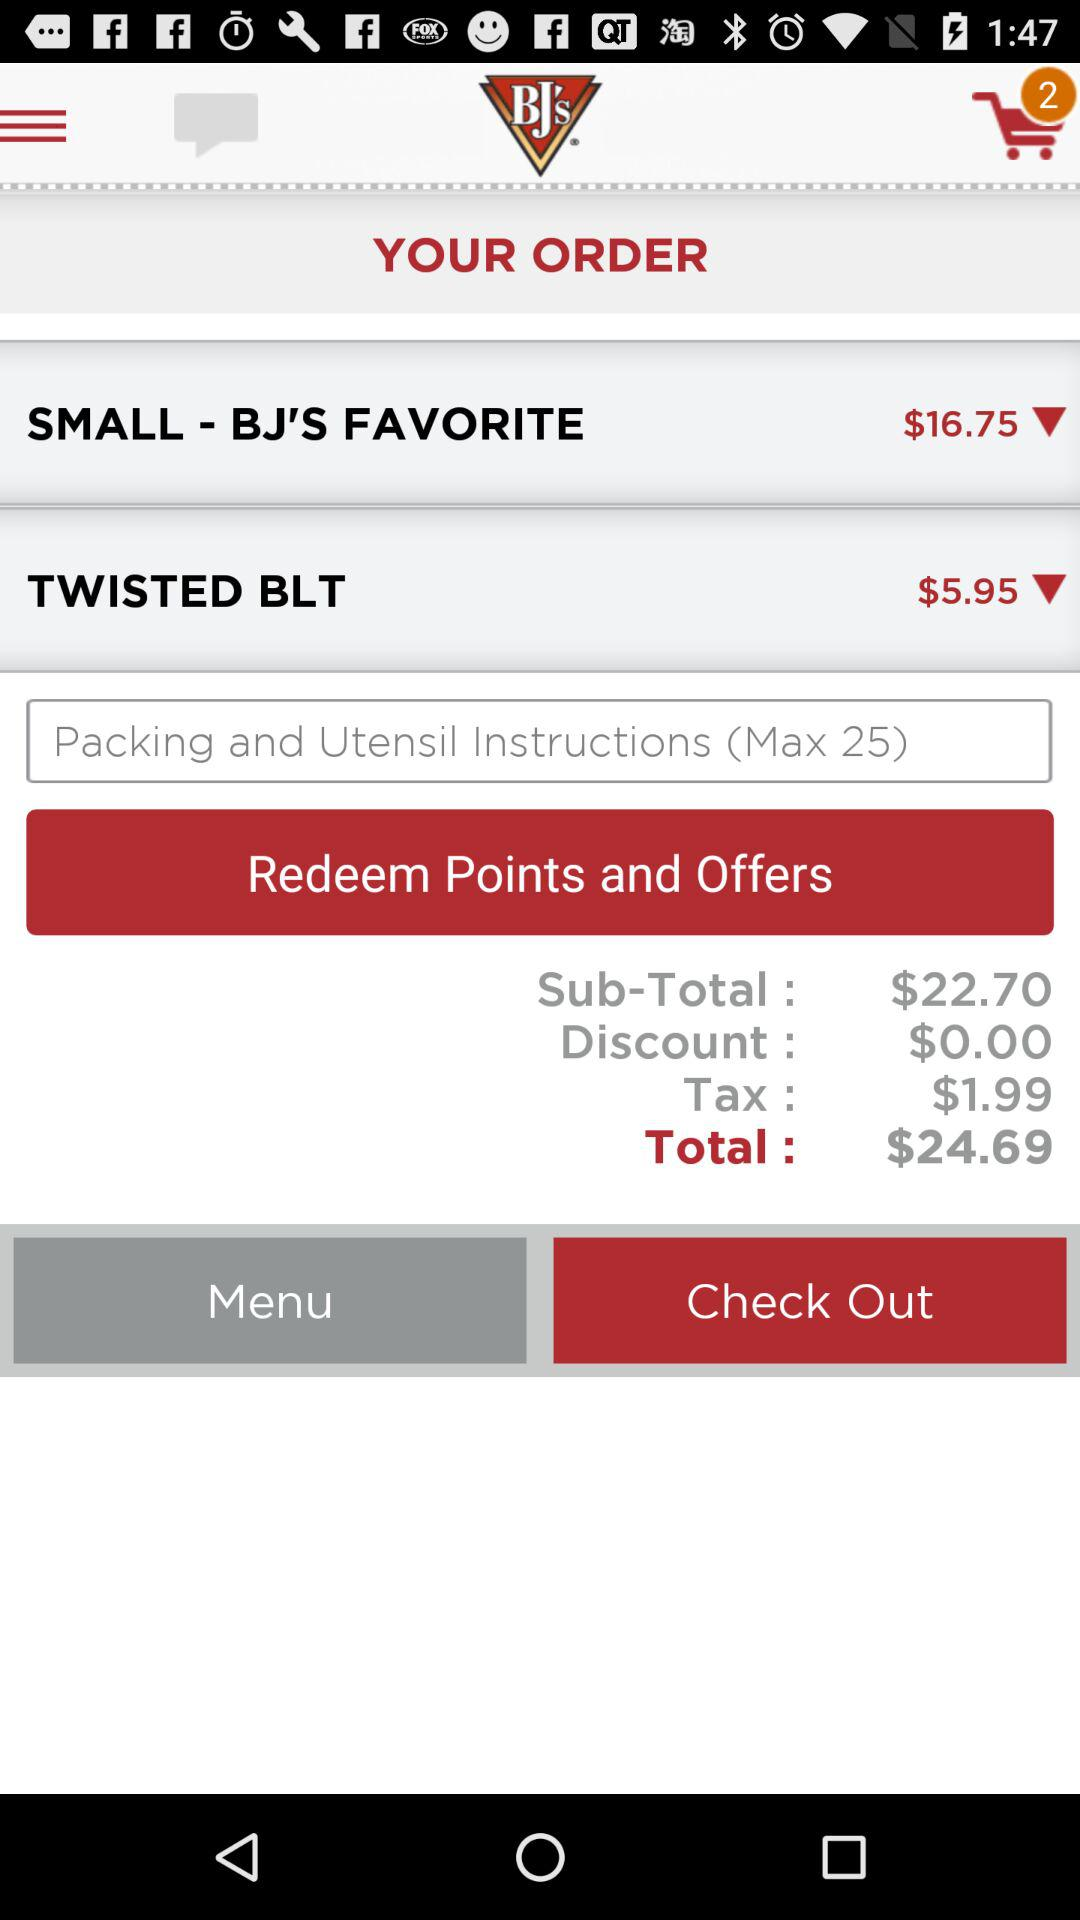What's the price of the "TWISTED BLT"? The price of the "TWISTED BLT" is $5.95. 